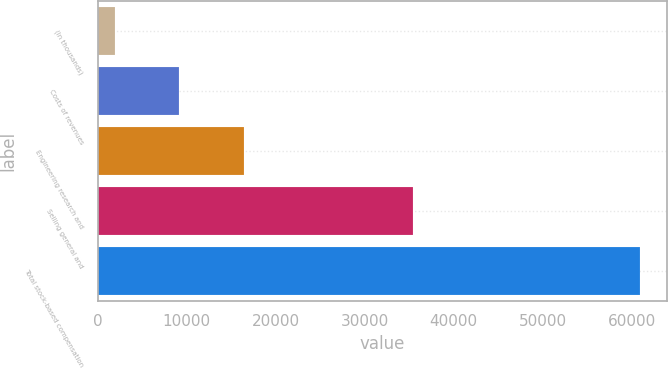Convert chart. <chart><loc_0><loc_0><loc_500><loc_500><bar_chart><fcel>(In thousands)<fcel>Costs of revenues<fcel>Engineering research and<fcel>Selling general and<fcel>Total stock-based compensation<nl><fcel>2014<fcel>9101<fcel>16397<fcel>35442<fcel>60940<nl></chart> 